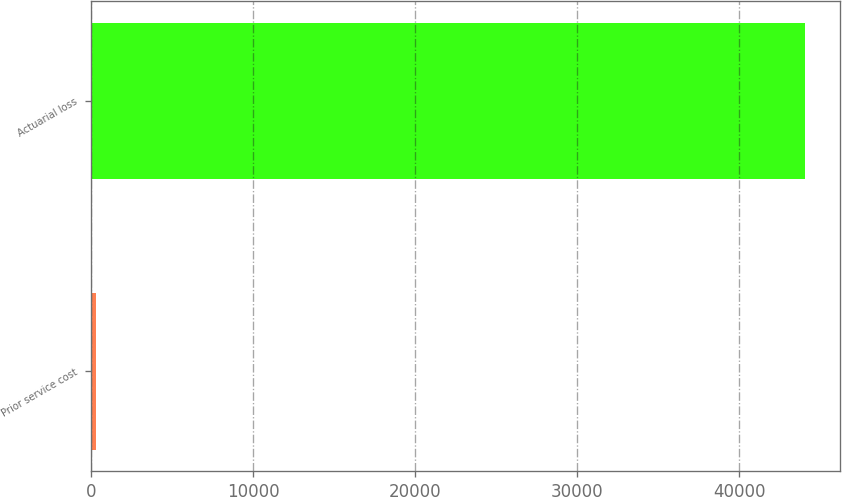Convert chart to OTSL. <chart><loc_0><loc_0><loc_500><loc_500><bar_chart><fcel>Prior service cost<fcel>Actuarial loss<nl><fcel>332<fcel>44026<nl></chart> 